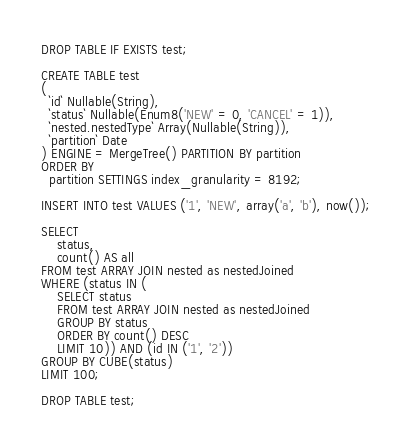<code> <loc_0><loc_0><loc_500><loc_500><_SQL_>DROP TABLE IF EXISTS test;

CREATE TABLE test
(
  `id` Nullable(String),
  `status` Nullable(Enum8('NEW' = 0, 'CANCEL' = 1)),
  `nested.nestedType` Array(Nullable(String)),
  `partition` Date
) ENGINE = MergeTree() PARTITION BY partition
ORDER BY
  partition SETTINGS index_granularity = 8192;

INSERT INTO test VALUES ('1', 'NEW', array('a', 'b'), now());

SELECT
    status,
    count() AS all
FROM test ARRAY JOIN nested as nestedJoined
WHERE (status IN (
    SELECT status
    FROM test ARRAY JOIN nested as nestedJoined
    GROUP BY status 
    ORDER BY count() DESC 
    LIMIT 10)) AND (id IN ('1', '2'))
GROUP BY CUBE(status)
LIMIT 100;

DROP TABLE test;
</code> 